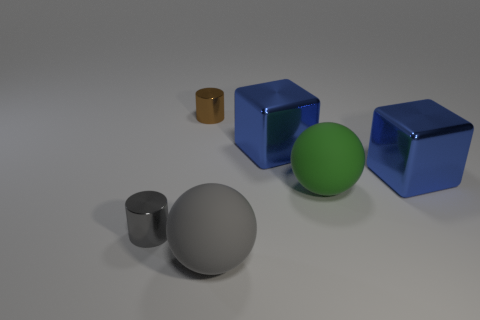Add 1 gray cylinders. How many objects exist? 7 Subtract 0 cyan balls. How many objects are left? 6 Subtract all big cyan metallic cylinders. Subtract all large matte things. How many objects are left? 4 Add 1 large balls. How many large balls are left? 3 Add 1 big blue metal blocks. How many big blue metal blocks exist? 3 